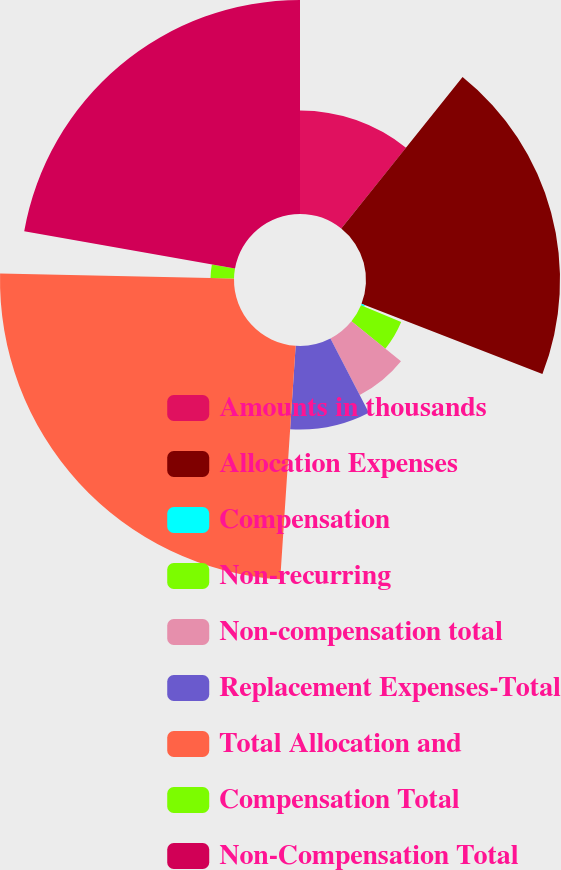Convert chart to OTSL. <chart><loc_0><loc_0><loc_500><loc_500><pie_chart><fcel>Amounts in thousands<fcel>Allocation Expenses<fcel>Compensation<fcel>Non-recurring<fcel>Non-compensation total<fcel>Replacement Expenses-Total<fcel>Total Allocation and<fcel>Compensation Total<fcel>Non-Compensation Total<nl><fcel>10.75%<fcel>20.14%<fcel>0.37%<fcel>4.52%<fcel>6.6%<fcel>8.67%<fcel>24.29%<fcel>2.44%<fcel>22.22%<nl></chart> 